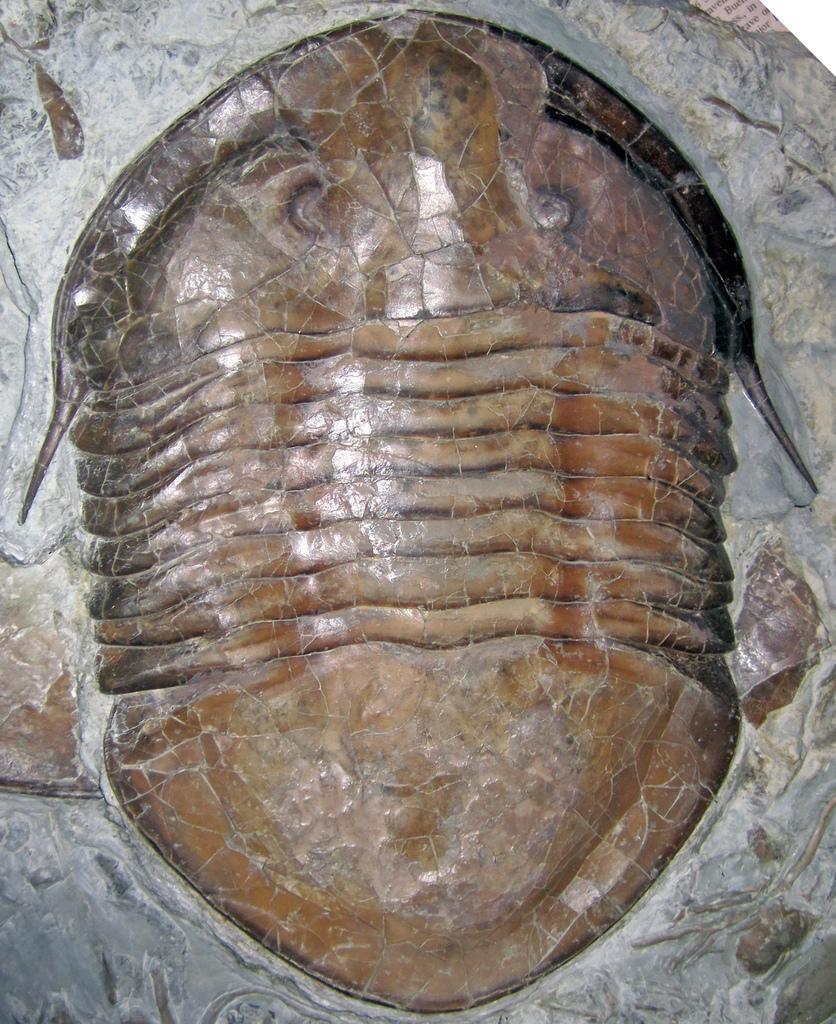How would you summarize this image in a sentence or two? In this image we can see a sculpture made of stone. 